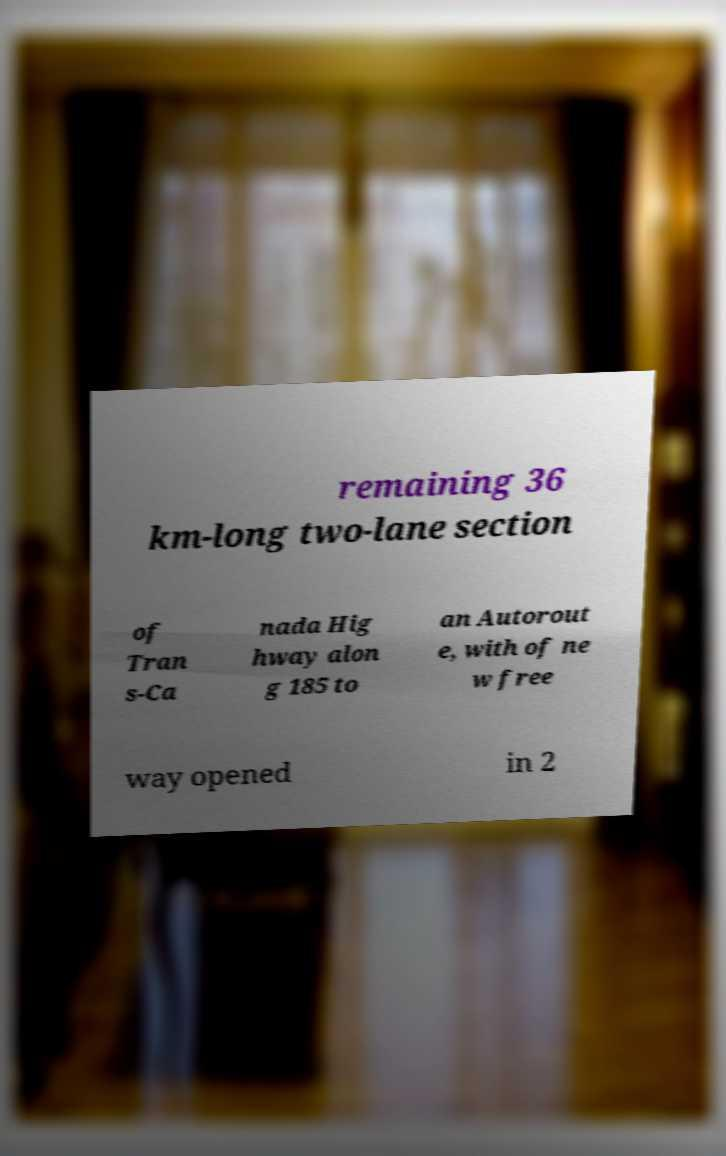What messages or text are displayed in this image? I need them in a readable, typed format. remaining 36 km-long two-lane section of Tran s-Ca nada Hig hway alon g 185 to an Autorout e, with of ne w free way opened in 2 